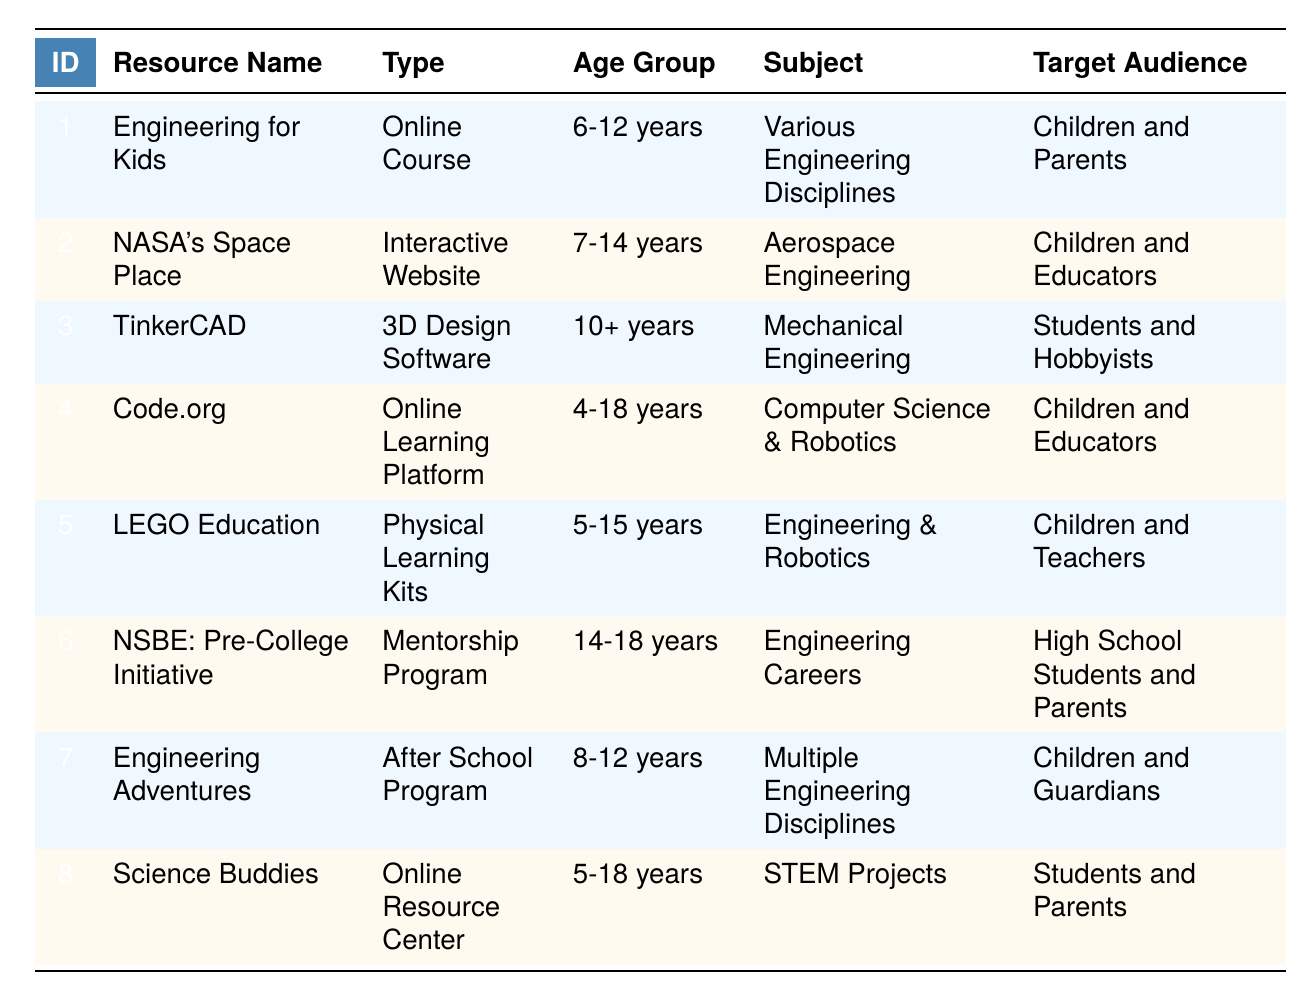What online course is targeted at children aged 6-12 years? The table indicates that the resource "Engineering for Kids" is targeted specifically at the age group of 6-12 years and is categorized as an online course.
Answer: Engineering for Kids Which resource is focused on aerospace engineering? By examining the "Subject" column in the table, one can see that "NASA's Space Place" is dedicated to aerospace engineering.
Answer: NASA's Space Place Are there any resources for children aged 4-18 years? The table shows that "Code.org" accommodates children between the ages of 4 to 18 years. Therefore, the answer is yes.
Answer: Yes What type of resource is "TinkerCAD"? Referring to the table, "TinkerCAD" is classified as 3D design software, as indicated in the "Type" column.
Answer: 3D Design Software Which resource has the target audience of high school students and parents? The "NSBE: Pre-College Initiative" is aimed specifically at high school students and their parents, as noted in the "Target Audience" section of the table.
Answer: NSBE: Pre-College Initiative How many resources are available for children aged 5-15 years? To find the resources for children aged 5-15 years, we check the "Age Group" column. Resources fitting this criteria are "LEGO Education" and "Science Buddies." Therefore, the count is 2.
Answer: 2 Is there a resource that integrates hands-on engineering projects? The "Engineering Adventures" program offers hands-on engineering projects, confirming that such a resource does exist.
Answer: Yes Which resource combines computer science and robotics for the youngest participants? The table specifies that "Code.org" includes computer science and robotics courses tailored for children aged 4 to 18 years, thus fulfilling the requirement of combining these subject areas for younger participants.
Answer: Code.org What are the age groups covered by "NASA's Space Place" and "TinkerCAD"? For "NASA's Space Place," the age group is 7-14 years, whereas "TinkerCAD" is for ages 10 and above. Collectively, they cover ages 7-14 years (NASA) and 10+ (TinkerCAD), so the answer requires stating both ranges.
Answer: 7-14 years; 10+ years Which resources target educators? The table indicates that both "NASA's Space Place" and "Code.org" specifically target educators as part of their audience, thus confirming that more than one resource serves this group.
Answer: NASA's Space Place; Code.org 